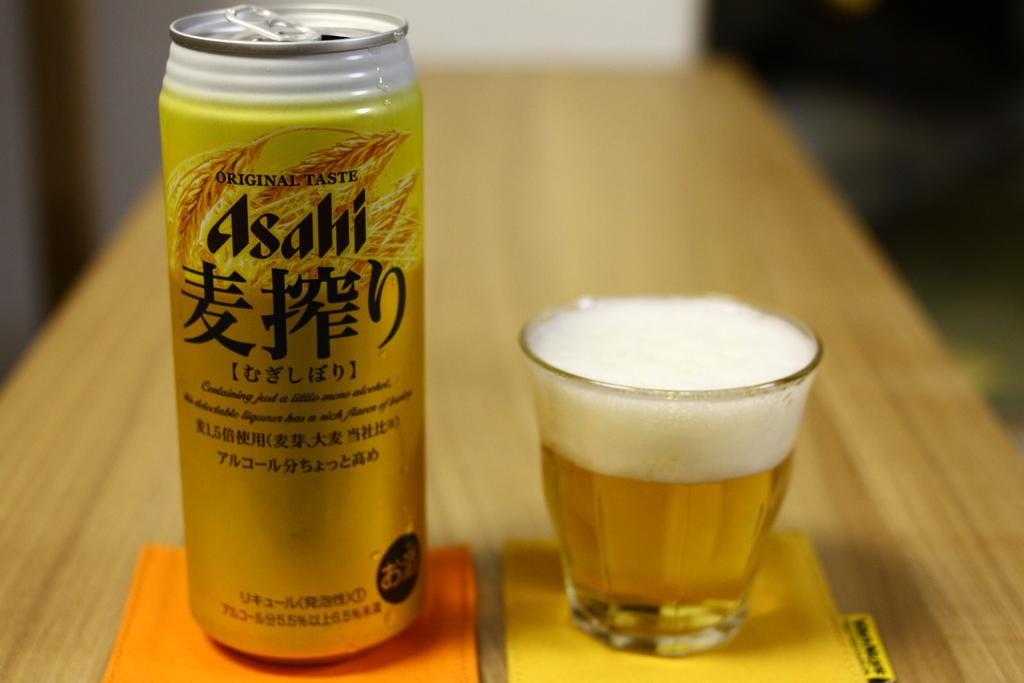<image>
Present a compact description of the photo's key features. the word original is on the gold can on the table 